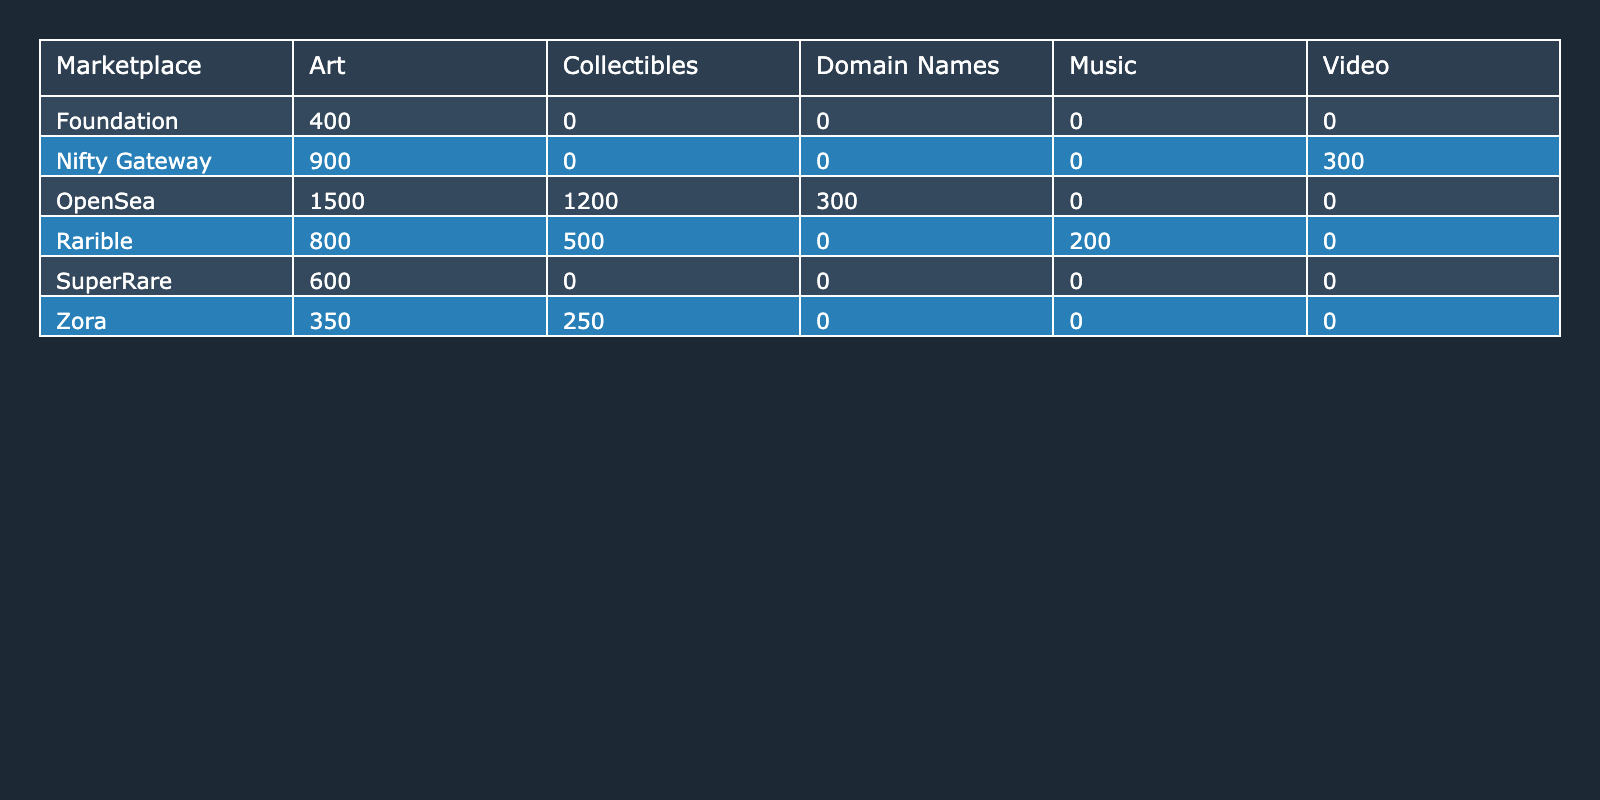What is the total number of NFT sales for the OpenSea marketplace? According to the table, OpenSea has three entries: Art (1500), Collectibles (1200), and Domain Names (300). We sum these values: 1500 + 1200 + 300 = 3000.
Answer: 3000 Which NFT type generated the most revenue on Rarible? Looking at the Rarible entries, we see Art generated 4000000, Collectibles 2500000, and Music 1000000. The highest value among these is 4000000 from Art.
Answer: Art What is the average sale price of Domain Names in OpenSea? The table shows that the average sale price of Domain Names in OpenSea is listed as 1000. This value is directly provided in the data.
Answer: 1000 Is the total revenue from Art NFTs in SuperRare greater than in Foundation? For SuperRare, the revenue from Art is 6000000, and for Foundation, it is 2000000. Since 6000000 is greater than 2000000, the answer is yes.
Answer: Yes What is the combined total sales for Collectibles across all marketplaces? From the table, we note the sales for Collectibles: OpenSea 1200, Rarible 500, and Zora 250. We sum these values: 1200 + 500 + 250 = 1950.
Answer: 1950 How much revenue did the Nifty Gateway generate from Video NFTs? The table shows that Nifty Gateway generated 1500000 from Video NFTs, which is directly stated in the data provided.
Answer: 1500000 Which marketplace has the highest total number of NFT sales? By trimming the numbers down: OpenSea has 3000 (1500 + 1200 + 300), Rarible has 1500 (800 + 500 + 200), SuperRare has 600, Foundation has 400, Zora has 600 (350 + 250), and Nifty Gateway has 1200 (900 + 300). OpenSea leads with 3000.
Answer: OpenSea What is the difference in total sales between Music and Collectibles in Rarible? Rarible records 200 for Music and 500 for Collectibles. The difference is calculated as: 500 - 200 = 300.
Answer: 300 How many total sales of Art NFTs were made across all marketplaces? The entries for Art NFTs are: OpenSea 1500, Rarible 800, SuperRare 600, Foundation 400, Zora 350, and Nifty Gateway 900. Adding these gives: 1500 + 800 + 600 + 400 + 350 + 900 = 4050.
Answer: 4050 